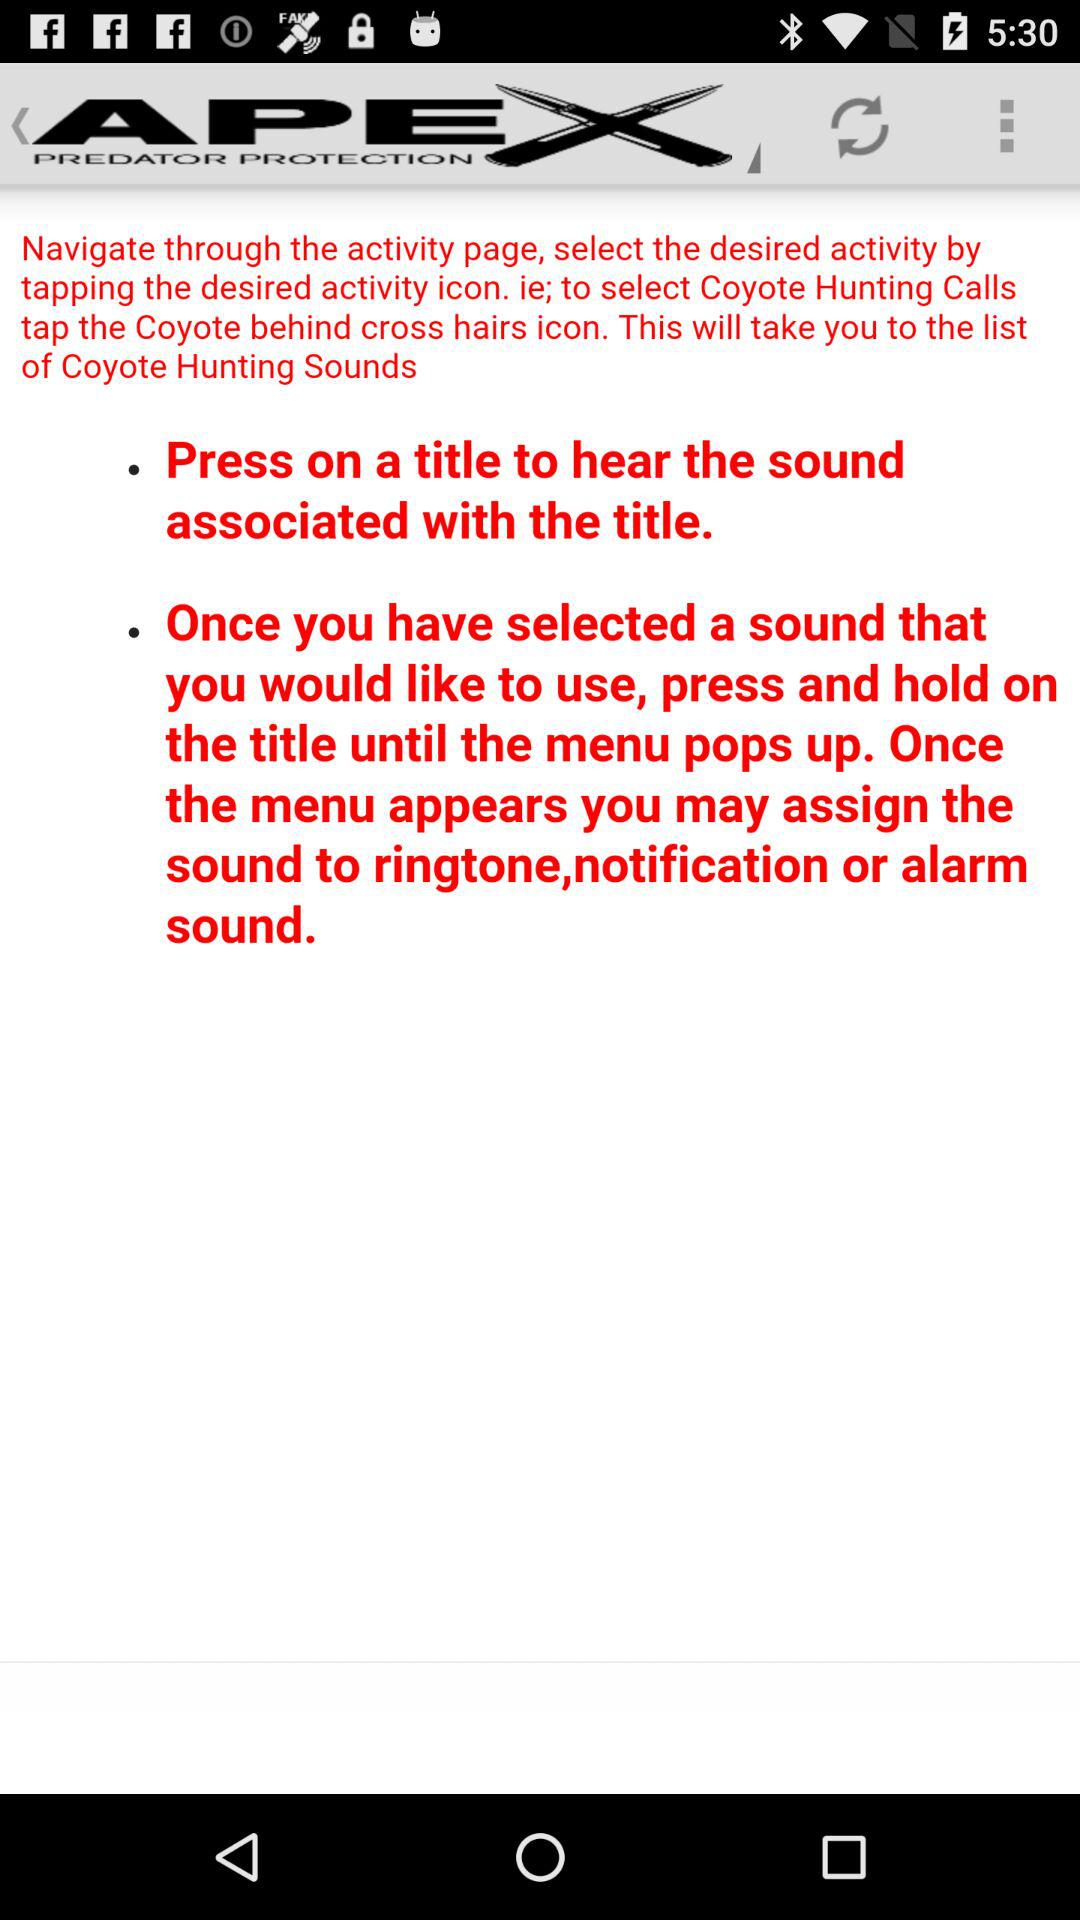How many black dots are on the screen?
Answer the question using a single word or phrase. 2 